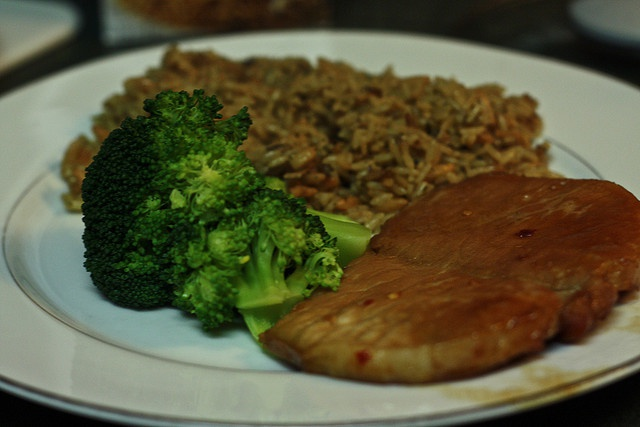Describe the objects in this image and their specific colors. I can see a broccoli in teal, black, darkgreen, and olive tones in this image. 